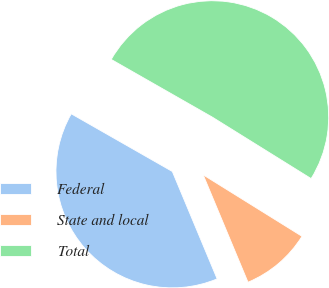<chart> <loc_0><loc_0><loc_500><loc_500><pie_chart><fcel>Federal<fcel>State and local<fcel>Total<nl><fcel>39.55%<fcel>9.85%<fcel>50.61%<nl></chart> 